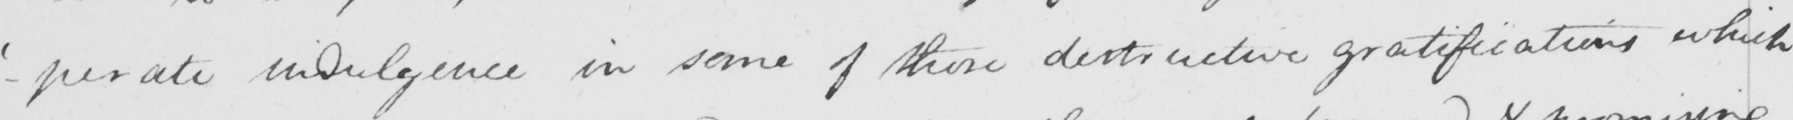Can you tell me what this handwritten text says? - ' perate  ' indulgence in some of those destructive gratifications which 